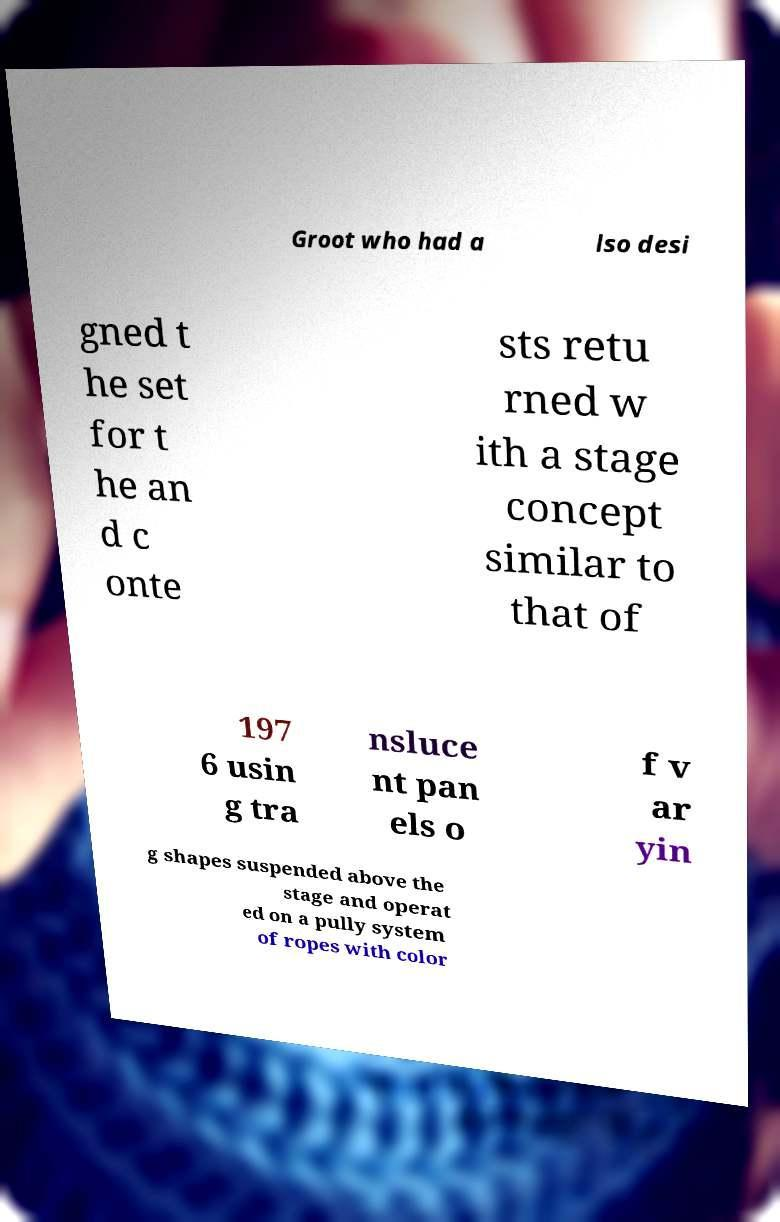Please identify and transcribe the text found in this image. Groot who had a lso desi gned t he set for t he an d c onte sts retu rned w ith a stage concept similar to that of 197 6 usin g tra nsluce nt pan els o f v ar yin g shapes suspended above the stage and operat ed on a pully system of ropes with color 